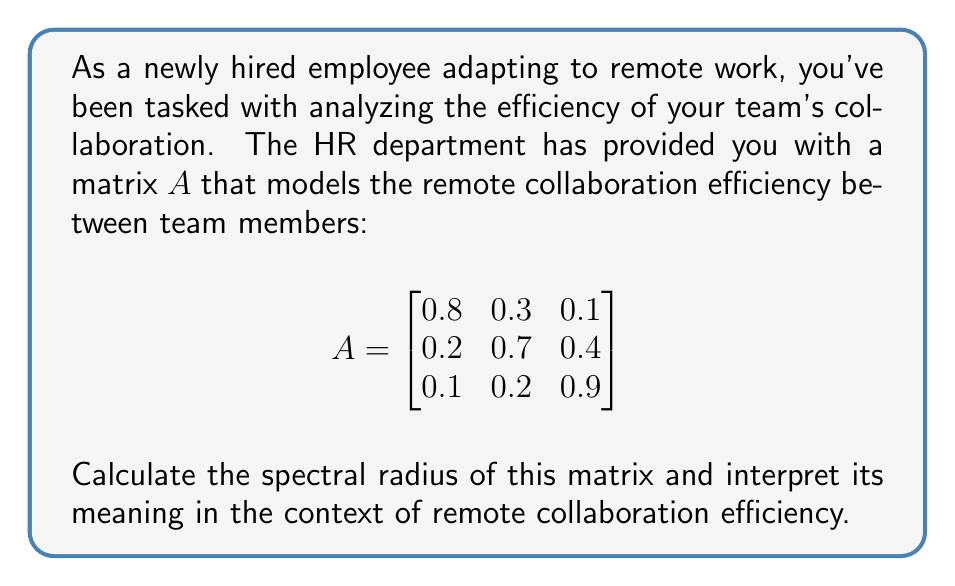Can you solve this math problem? To solve this problem, we'll follow these steps:

1) First, recall that the spectral radius $\rho(A)$ is the maximum of the absolute values of the eigenvalues of $A$.

2) To find the eigenvalues, we need to solve the characteristic equation:

   $\det(A - \lambda I) = 0$

3) Expanding this:

   $$\begin{vmatrix}
   0.8-\lambda & 0.3 & 0.1 \\
   0.2 & 0.7-\lambda & 0.4 \\
   0.1 & 0.2 & 0.9-\lambda
   \end{vmatrix} = 0$$

4) This gives us the cubic equation:

   $-\lambda^3 + 2.4\lambda^2 - 1.71\lambda + 0.362 = 0$

5) Solving this equation (using a computer algebra system or numerical methods), we get the eigenvalues:

   $\lambda_1 \approx 1.2095$
   $\lambda_2 \approx 0.6398$
   $\lambda_3 \approx 0.5507$

6) The spectral radius is the maximum of the absolute values of these eigenvalues:

   $\rho(A) = \max(|\lambda_1|, |\lambda_2|, |\lambda_3|) \approx 1.2095$

7) Interpretation: In the context of remote collaboration efficiency, the spectral radius being greater than 1 suggests that the collaboration efficiency is increasing over time. This could indicate that the team is adapting well to remote work, with efficiency improving as they become more familiar with remote collaboration tools and processes.
Answer: The spectral radius of the matrix $A$ is approximately 1.2095. This value being greater than 1 suggests that the remote collaboration efficiency of the team is improving over time, indicating successful adaptation to remote work. 